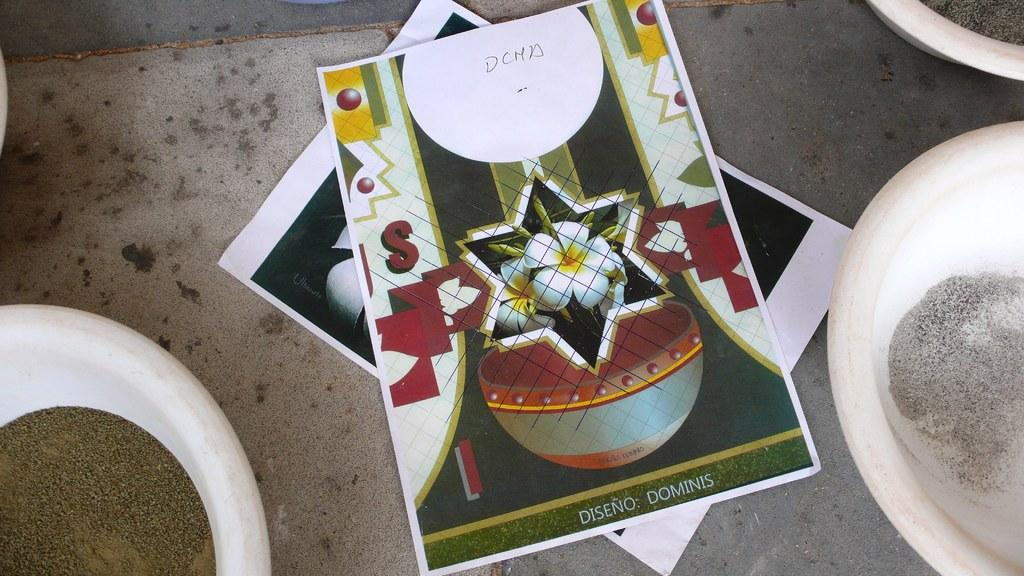What can be seen hanging on the walls in the image? There are posters in the image. What type of objects are on a surface in the image? There are bowls on a surface in the image. What type of cheese is visible in the image? There is no cheese present in the image. How many heads can be seen in the image? There are no heads visible in the image. What type of container is present in the image? There is no container, such as a pail, present in the image. 